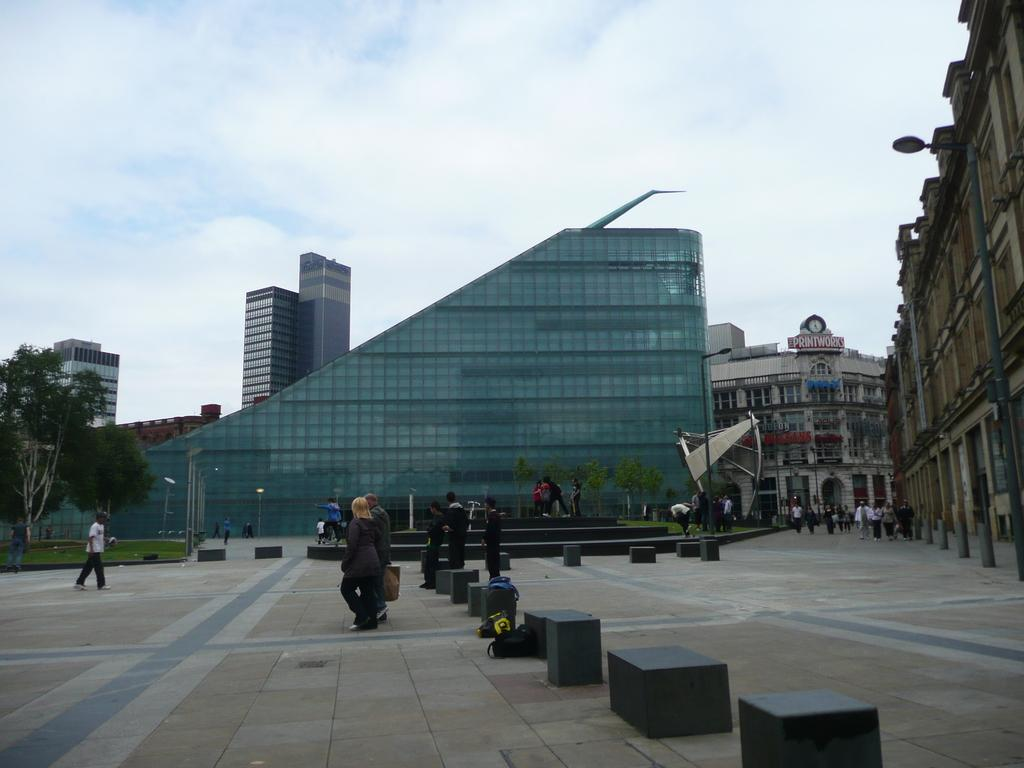What objects can be seen in the image? There are bags and blocks in the image. What activity is being performed by the groups of people in the image? The groups of people are walking in the image. What type of surface do the people walk on? There is a pathway in the image for the people to walk on. What structures are present in the image? There are buildings in the image. What type of vegetation is present in the image? There are trees in the image. What type of lighting is present in the image? There are street lights in the image. What can be seen in the background of the image? The sky is visible in the background of the image. What is the rate of zinc production in the image? There is no information about zinc production in the image, as it focuses on bags, blocks, people walking, a pathway, buildings, trees, street lights, and the sky. 